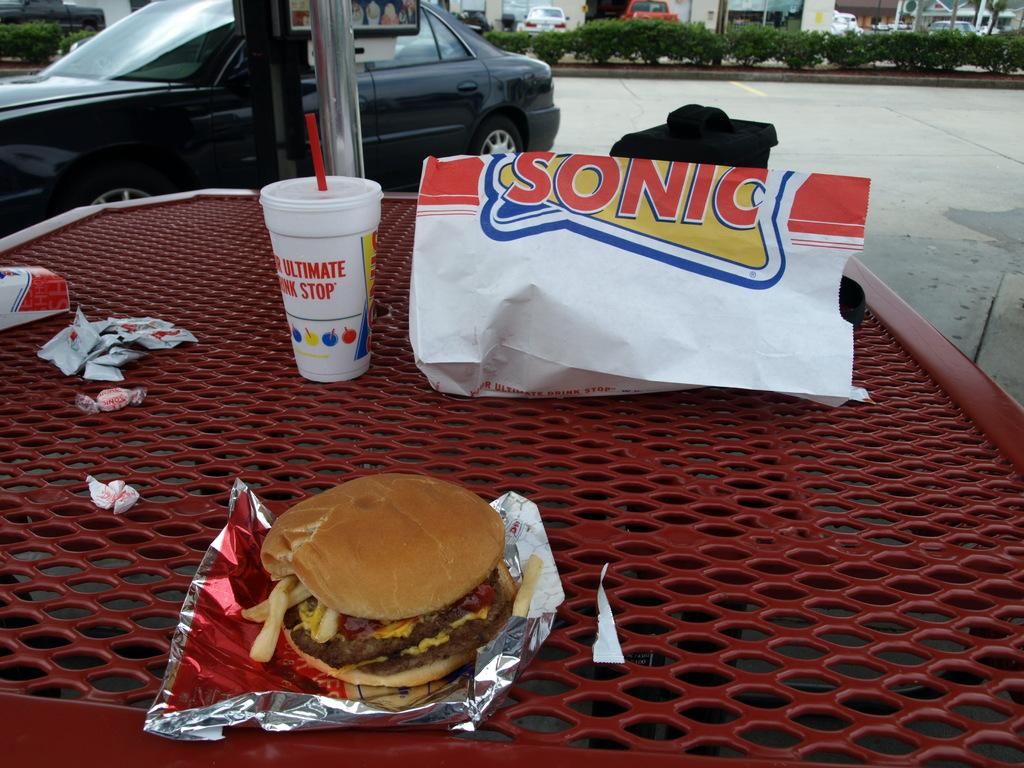What type of food is visible in the image? There is a burger in the image. What items are present for condiments or additional flavors? There are sachets in the image. What type of container is present for the food items? There is a paper bag in the image. What is the beverage container in the image? There is a cup with a straw in the image. What type of vehicles can be seen in the image? There are cars parked in the image. What type of structures are visible in the image? There are buildings in the image. What type of natural elements are present in the image? There are plants in the image. What type of instrument is being played by the astronaut in the image? There are no astronauts or instruments present in the image. What type of bone can be seen in the image? There are no bones visible in the image. 